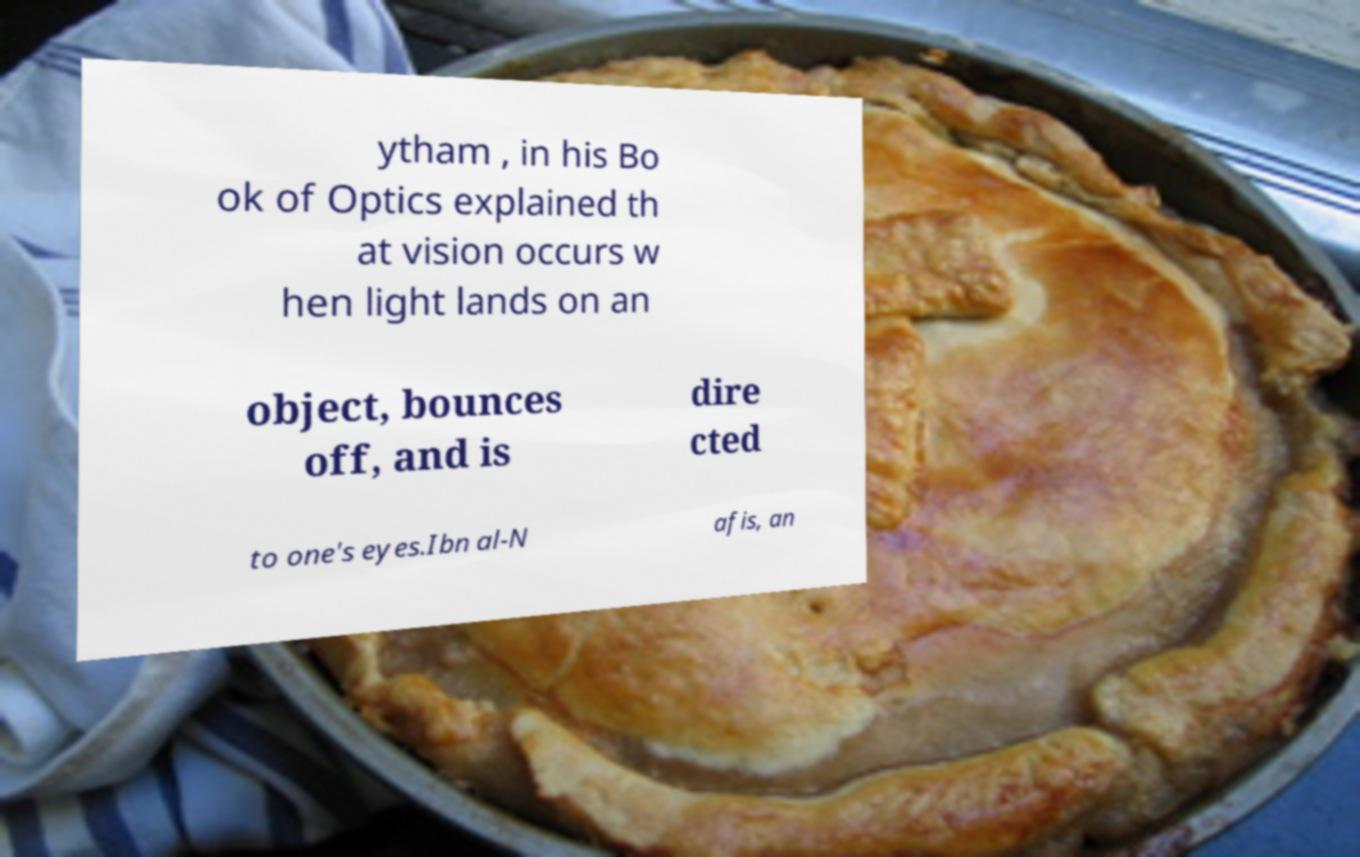What messages or text are displayed in this image? I need them in a readable, typed format. ytham , in his Bo ok of Optics explained th at vision occurs w hen light lands on an object, bounces off, and is dire cted to one's eyes.Ibn al-N afis, an 